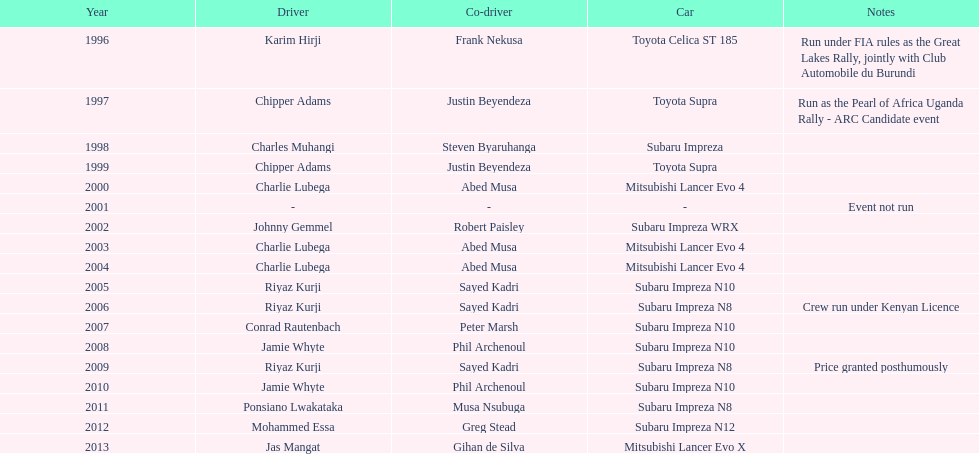Which driver was victorious after ponsiano lwakataka? Mohammed Essa. 